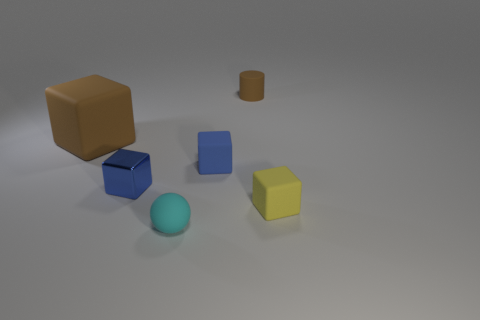Subtract all tiny shiny blocks. How many blocks are left? 3 Subtract all blue cubes. How many cubes are left? 2 Subtract all balls. How many objects are left? 5 Subtract all gray balls. How many blue blocks are left? 2 Subtract 3 cubes. How many cubes are left? 1 Add 4 blue cylinders. How many objects exist? 10 Subtract all yellow spheres. Subtract all cyan cubes. How many spheres are left? 1 Add 6 yellow rubber cubes. How many yellow rubber cubes are left? 7 Add 3 tiny yellow metal blocks. How many tiny yellow metal blocks exist? 3 Subtract 0 red balls. How many objects are left? 6 